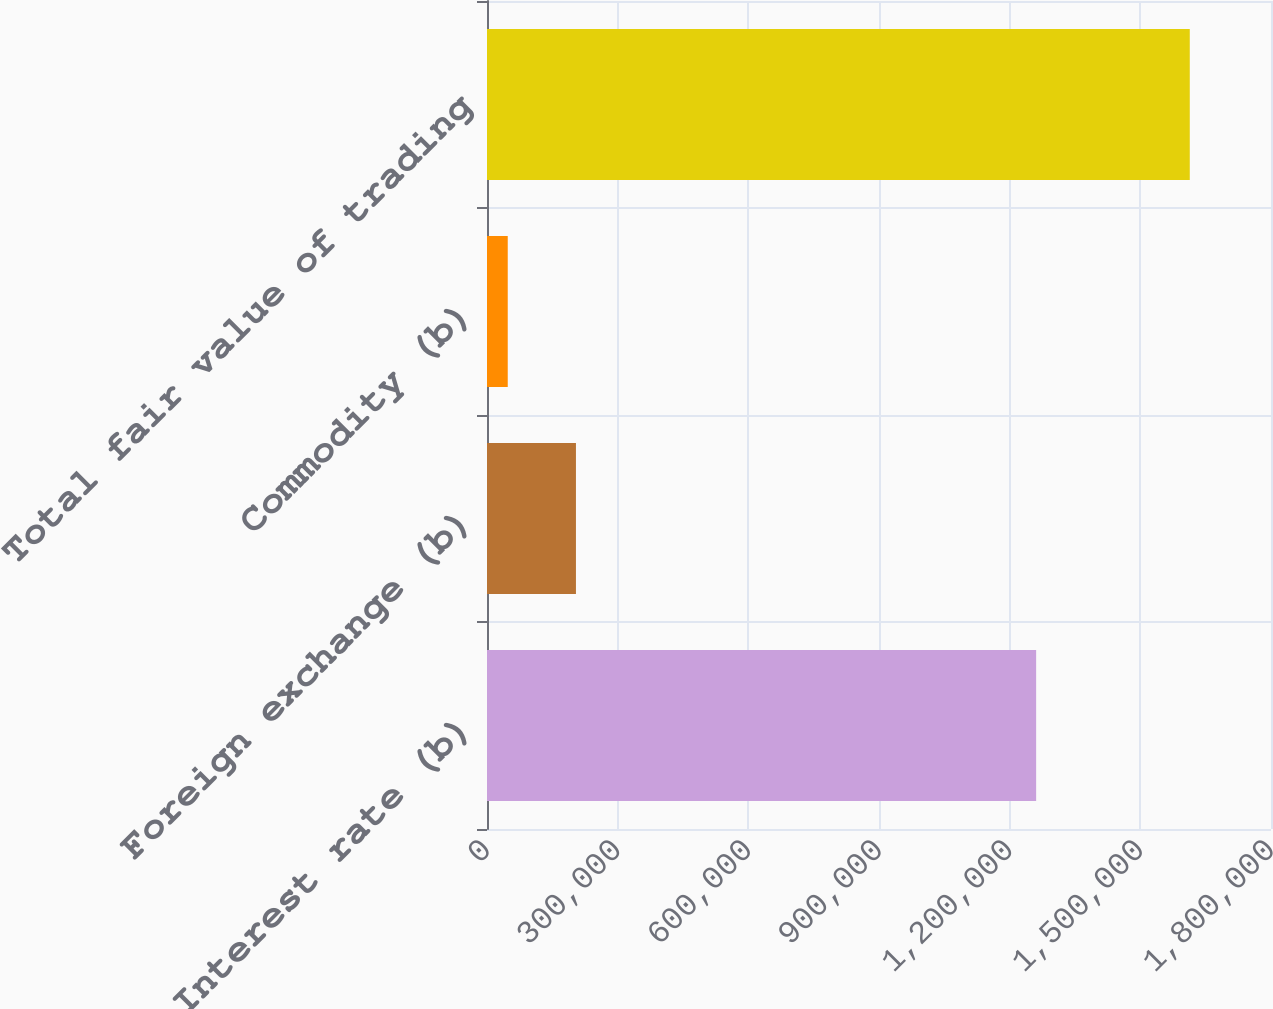Convert chart to OTSL. <chart><loc_0><loc_0><loc_500><loc_500><bar_chart><fcel>Interest rate (b)<fcel>Foreign exchange (b)<fcel>Commodity (b)<fcel>Total fair value of trading<nl><fcel>1.26077e+06<fcel>204214<fcel>47625<fcel>1.61351e+06<nl></chart> 